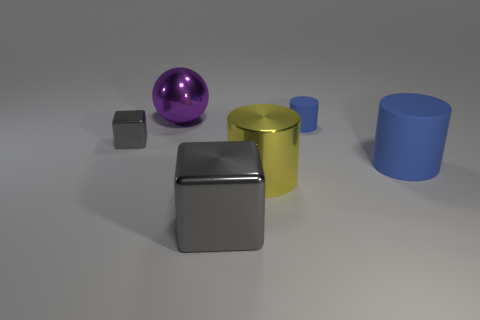What size is the thing that is the same color as the large block?
Provide a short and direct response. Small. There is a large block; does it have the same color as the object on the left side of the big purple ball?
Your answer should be very brief. Yes. Are there any blue matte cylinders of the same size as the shiny cylinder?
Make the answer very short. Yes. Do the large object that is to the right of the yellow object and the large yellow object have the same shape?
Give a very brief answer. Yes. There is a tiny thing to the right of the big gray object; what is it made of?
Offer a terse response. Rubber. There is a gray object that is behind the large gray thing in front of the purple sphere; what is its shape?
Your answer should be compact. Cube. Is the shape of the big gray thing the same as the gray object to the left of the large gray metal thing?
Make the answer very short. Yes. How many objects are right of the object in front of the shiny cylinder?
Give a very brief answer. 3. What is the material of the other blue object that is the same shape as the big blue object?
Make the answer very short. Rubber. What number of purple objects are either large shiny balls or big cylinders?
Offer a very short reply. 1. 